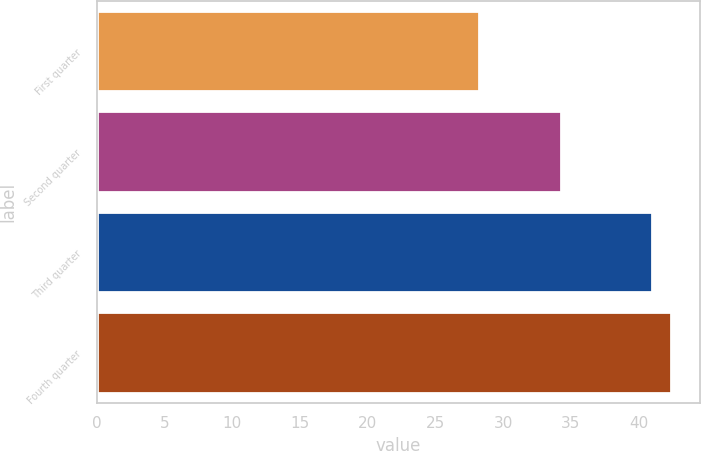Convert chart to OTSL. <chart><loc_0><loc_0><loc_500><loc_500><bar_chart><fcel>First quarter<fcel>Second quarter<fcel>Third quarter<fcel>Fourth quarter<nl><fcel>28.18<fcel>34.25<fcel>41.01<fcel>42.39<nl></chart> 